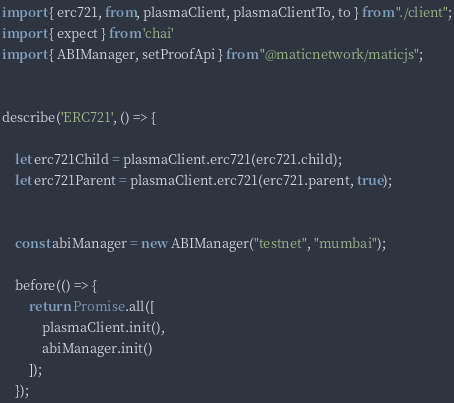Convert code to text. <code><loc_0><loc_0><loc_500><loc_500><_TypeScript_>import { erc721, from, plasmaClient, plasmaClientTo, to } from "./client";
import { expect } from 'chai'
import { ABIManager, setProofApi } from "@maticnetwork/maticjs";


describe('ERC721', () => {

    let erc721Child = plasmaClient.erc721(erc721.child);
    let erc721Parent = plasmaClient.erc721(erc721.parent, true);


    const abiManager = new ABIManager("testnet", "mumbai");

    before(() => {
        return Promise.all([
            plasmaClient.init(),
            abiManager.init()
        ]);
    });
</code> 